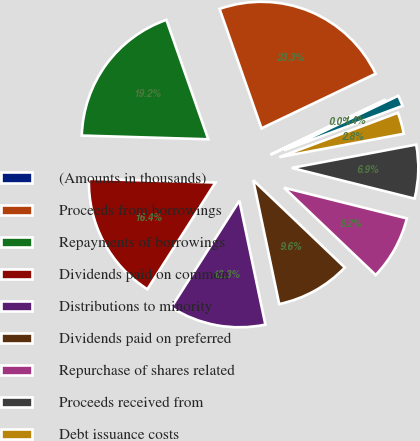<chart> <loc_0><loc_0><loc_500><loc_500><pie_chart><fcel>(Amounts in thousands)<fcel>Proceeds from borrowings<fcel>Repayments of borrowings<fcel>Dividends paid on common<fcel>Distributions to minority<fcel>Dividends paid on preferred<fcel>Repurchase of shares related<fcel>Proceeds received from<fcel>Debt issuance costs<fcel>Net cash provided by financing<nl><fcel>0.02%<fcel>23.27%<fcel>19.16%<fcel>16.43%<fcel>12.33%<fcel>9.59%<fcel>8.22%<fcel>6.85%<fcel>2.75%<fcel>1.38%<nl></chart> 